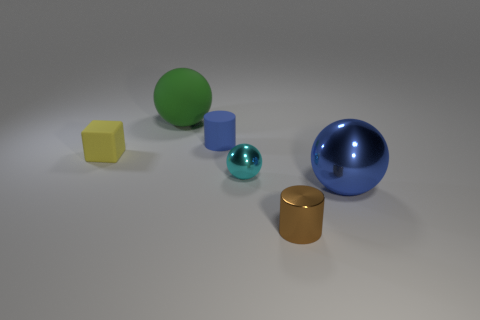Add 2 small gray spheres. How many objects exist? 8 Subtract all brown cylinders. How many cylinders are left? 1 Subtract all metal spheres. How many spheres are left? 1 Subtract 2 spheres. How many spheres are left? 1 Subtract all cylinders. How many objects are left? 4 Subtract all brown balls. How many gray cylinders are left? 0 Subtract all small cyan things. Subtract all tiny metallic spheres. How many objects are left? 4 Add 2 tiny brown cylinders. How many tiny brown cylinders are left? 3 Add 1 big purple shiny cylinders. How many big purple shiny cylinders exist? 1 Subtract 0 blue blocks. How many objects are left? 6 